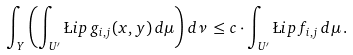Convert formula to latex. <formula><loc_0><loc_0><loc_500><loc_500>\int _ { Y } \left ( \int _ { U ^ { \prime } } \L i p \, g _ { i , j } ( x , y ) \, d \mu \right ) d \nu \, \leq c \cdot \int _ { U ^ { \prime } } \L i p \, f _ { i , j } \, d \mu \, .</formula> 